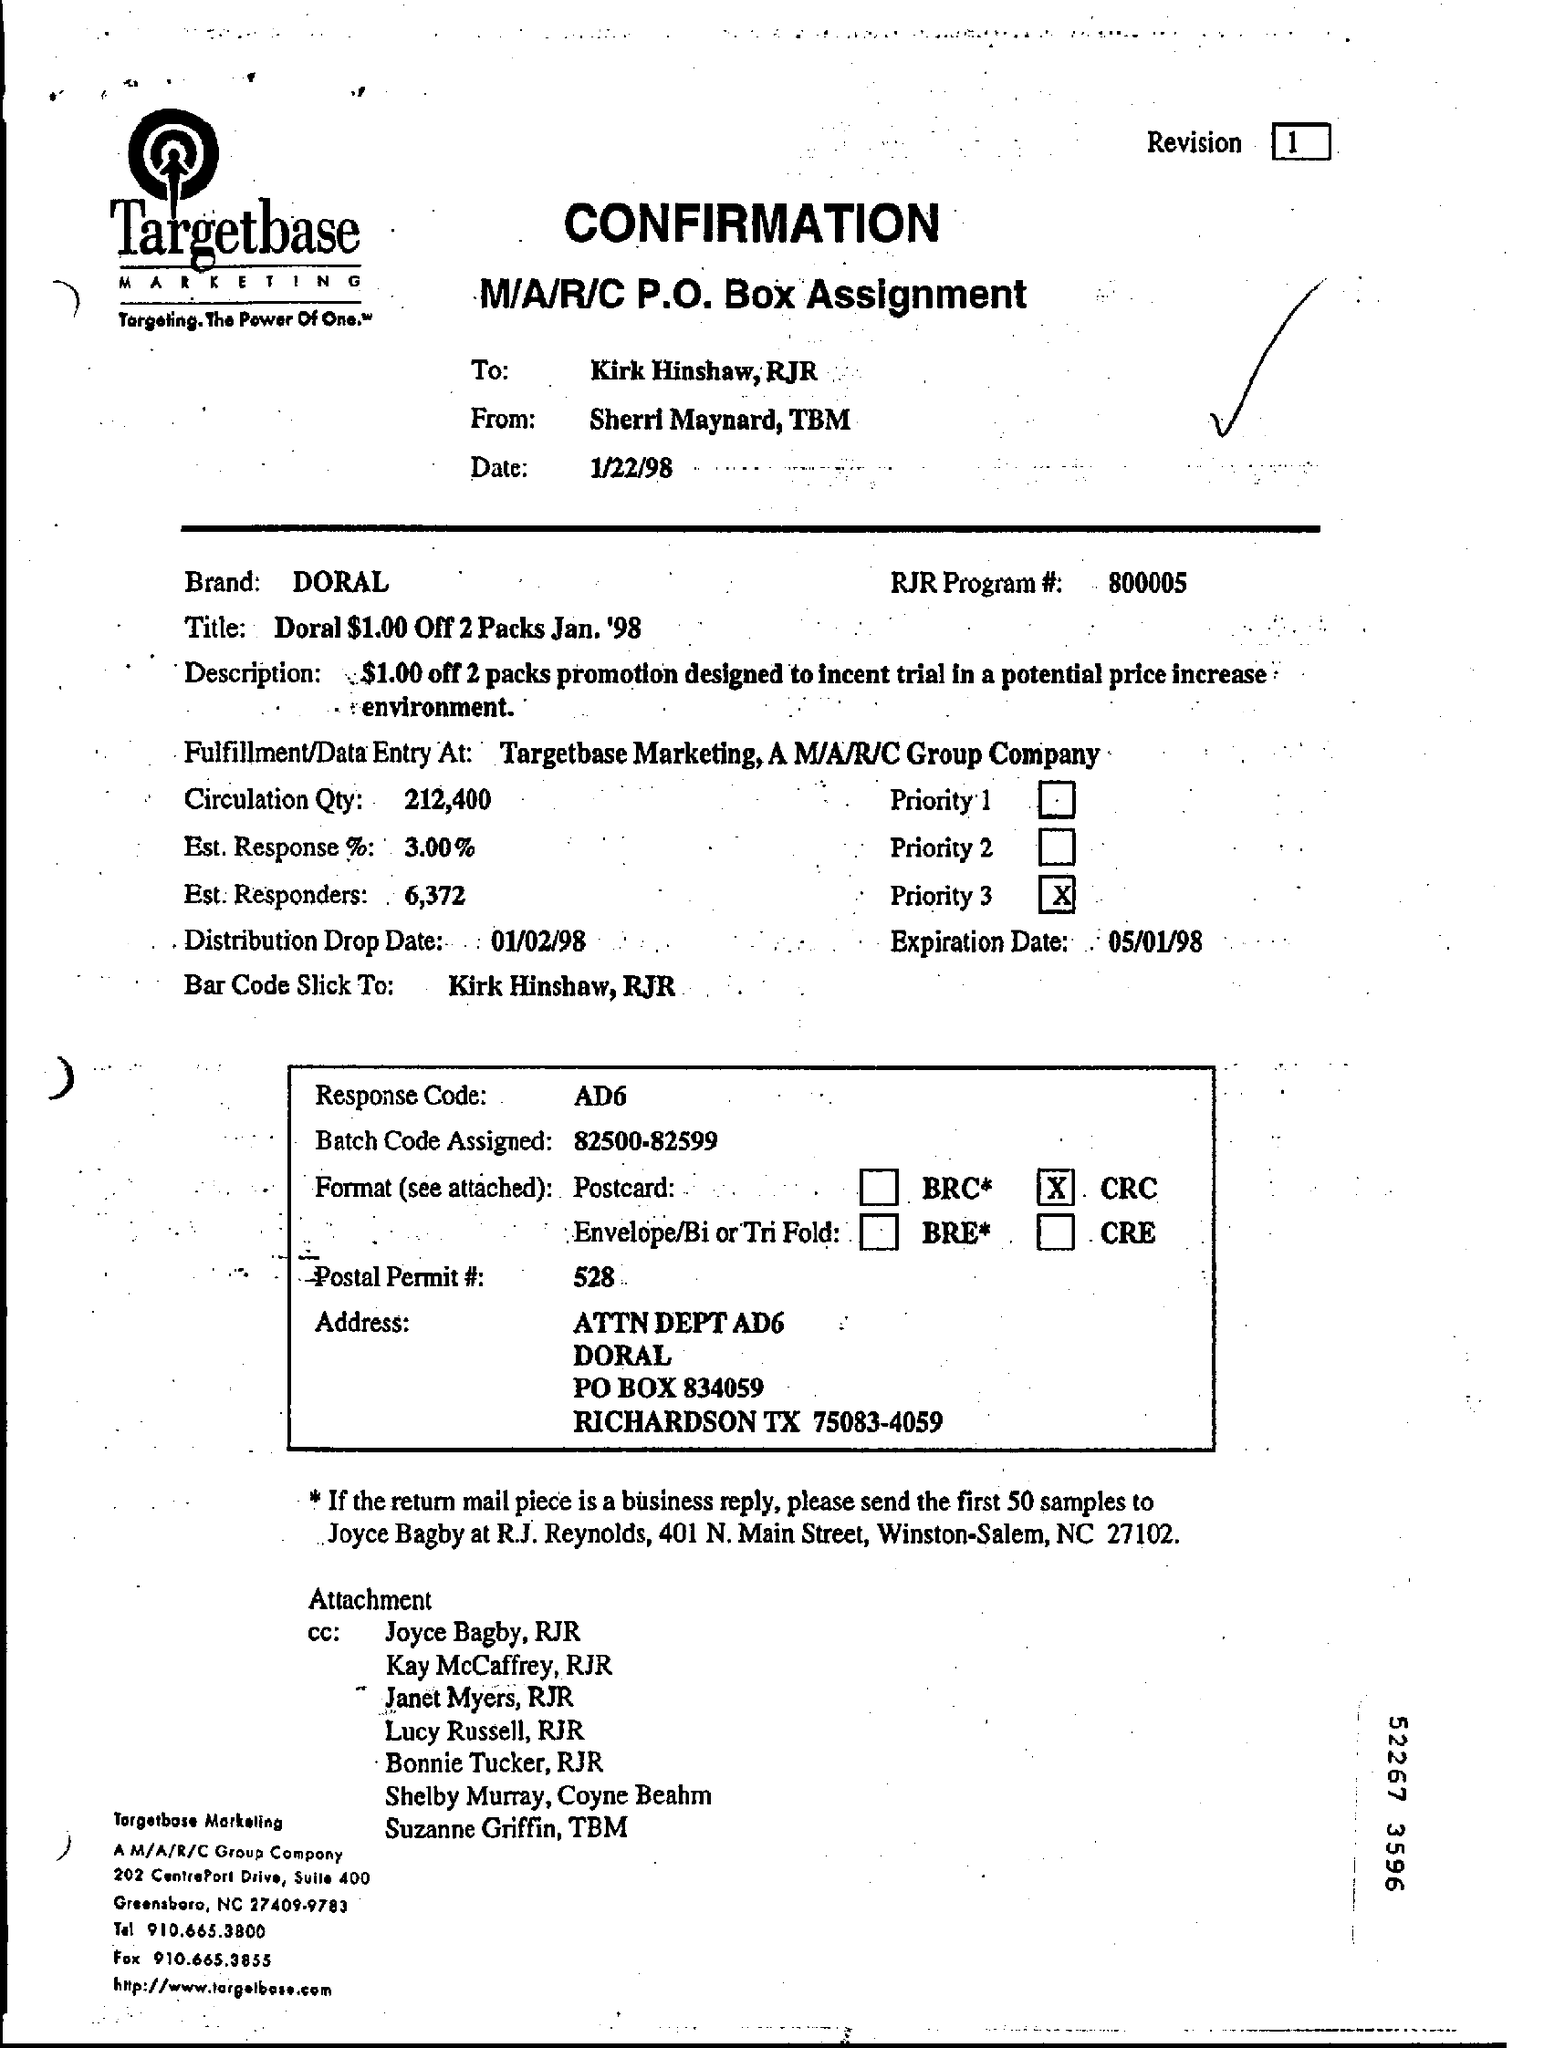List a handful of essential elements in this visual. The sender of the Confirmation document is Sherri Maynard, TBM. The recipient of the Confirmation document is Kirk Hinshaw, and the sender is RJR. The response code mentioned in the document is AD6. The batch code assigned in accordance with the document is within the range of 82500-82599. The RJR Program #(no) mentioned in the document is 800005. 